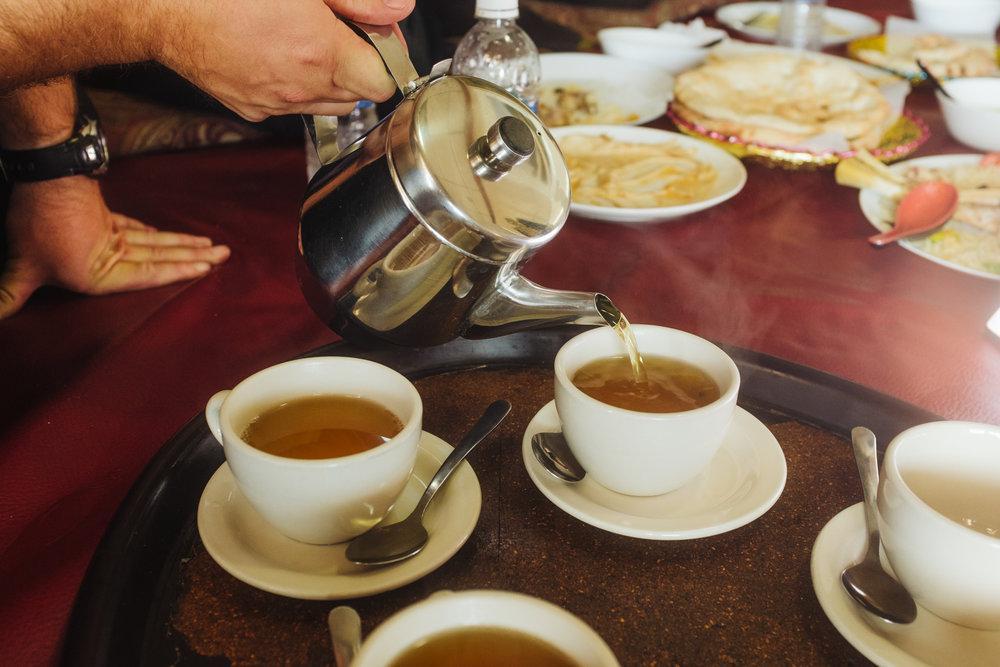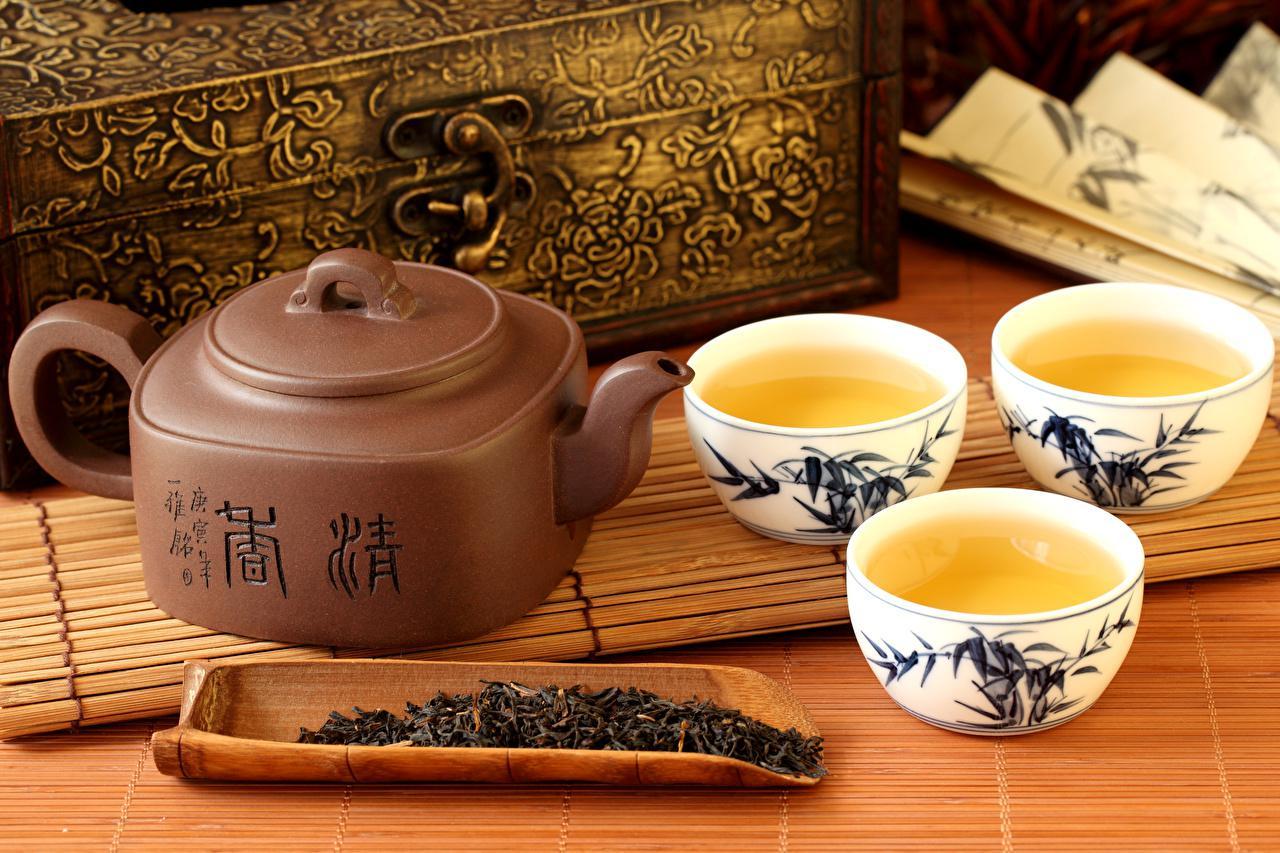The first image is the image on the left, the second image is the image on the right. Given the left and right images, does the statement "Tea is being poured from a teapot into one of the white tea cups." hold true? Answer yes or no. Yes. The first image is the image on the left, the second image is the image on the right. Analyze the images presented: Is the assertion "tea is being poured from a spout" valid? Answer yes or no. Yes. 